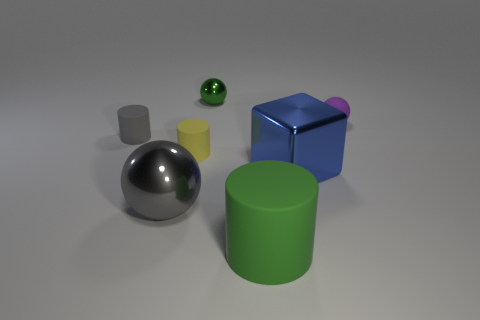Is there any other thing that is the same material as the big gray sphere?
Give a very brief answer. Yes. There is a thing that is in front of the tiny yellow thing and on the left side of the yellow rubber thing; what is its size?
Make the answer very short. Large. Are there more green objects that are in front of the small green thing than tiny rubber balls in front of the cube?
Offer a very short reply. Yes. Does the large blue metallic object have the same shape as the big shiny object left of the blue shiny object?
Your response must be concise. No. How many other things are the same shape as the big blue object?
Offer a very short reply. 0. What color is the matte thing that is behind the big gray metallic ball and to the right of the tiny yellow rubber cylinder?
Your answer should be compact. Purple. What is the color of the small rubber ball?
Offer a very short reply. Purple. Does the purple sphere have the same material as the gray thing that is behind the small yellow matte cylinder?
Ensure brevity in your answer.  Yes. There is a big gray thing that is the same material as the blue cube; what is its shape?
Provide a succinct answer. Sphere. There is a rubber sphere that is the same size as the green shiny ball; what color is it?
Provide a short and direct response. Purple. 